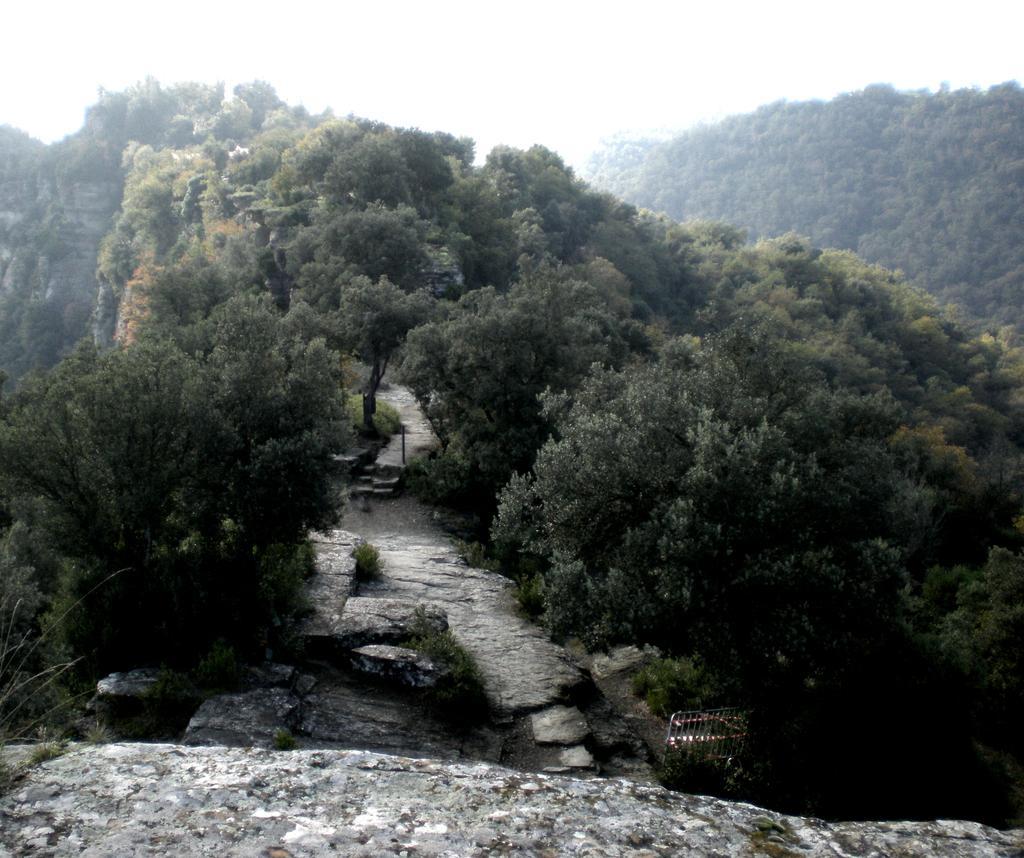Can you describe this image briefly? In this image we can see rock hills, trees and the sky in the background. 